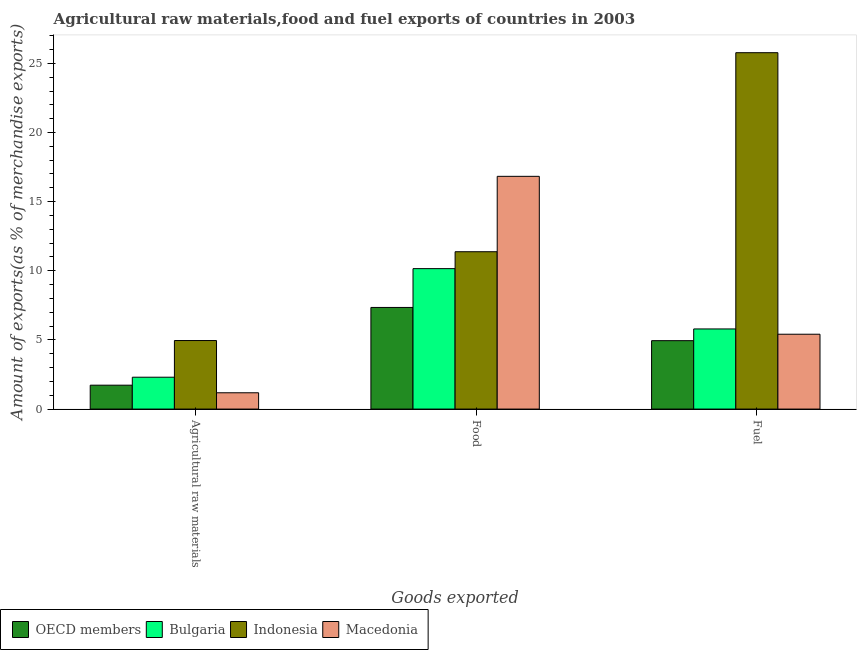Are the number of bars on each tick of the X-axis equal?
Your response must be concise. Yes. How many bars are there on the 1st tick from the left?
Give a very brief answer. 4. What is the label of the 2nd group of bars from the left?
Your response must be concise. Food. What is the percentage of food exports in OECD members?
Keep it short and to the point. 7.35. Across all countries, what is the maximum percentage of food exports?
Make the answer very short. 16.83. Across all countries, what is the minimum percentage of raw materials exports?
Ensure brevity in your answer.  1.18. In which country was the percentage of raw materials exports maximum?
Your answer should be very brief. Indonesia. What is the total percentage of fuel exports in the graph?
Your answer should be very brief. 41.93. What is the difference between the percentage of food exports in Bulgaria and that in Indonesia?
Give a very brief answer. -1.22. What is the difference between the percentage of raw materials exports in OECD members and the percentage of food exports in Indonesia?
Ensure brevity in your answer.  -9.65. What is the average percentage of food exports per country?
Your answer should be very brief. 11.43. What is the difference between the percentage of raw materials exports and percentage of food exports in OECD members?
Offer a very short reply. -5.62. What is the ratio of the percentage of raw materials exports in OECD members to that in Macedonia?
Offer a terse response. 1.47. What is the difference between the highest and the second highest percentage of food exports?
Provide a short and direct response. 5.45. What is the difference between the highest and the lowest percentage of food exports?
Provide a short and direct response. 9.48. In how many countries, is the percentage of fuel exports greater than the average percentage of fuel exports taken over all countries?
Your response must be concise. 1. Is the sum of the percentage of fuel exports in Indonesia and Macedonia greater than the maximum percentage of raw materials exports across all countries?
Ensure brevity in your answer.  Yes. What does the 2nd bar from the right in Fuel represents?
Provide a short and direct response. Indonesia. Is it the case that in every country, the sum of the percentage of raw materials exports and percentage of food exports is greater than the percentage of fuel exports?
Ensure brevity in your answer.  No. Are all the bars in the graph horizontal?
Make the answer very short. No. How many countries are there in the graph?
Offer a very short reply. 4. Does the graph contain any zero values?
Your answer should be compact. No. How many legend labels are there?
Provide a short and direct response. 4. How are the legend labels stacked?
Your answer should be very brief. Horizontal. What is the title of the graph?
Your answer should be very brief. Agricultural raw materials,food and fuel exports of countries in 2003. Does "Caribbean small states" appear as one of the legend labels in the graph?
Offer a terse response. No. What is the label or title of the X-axis?
Provide a succinct answer. Goods exported. What is the label or title of the Y-axis?
Provide a succinct answer. Amount of exports(as % of merchandise exports). What is the Amount of exports(as % of merchandise exports) in OECD members in Agricultural raw materials?
Offer a terse response. 1.73. What is the Amount of exports(as % of merchandise exports) of Bulgaria in Agricultural raw materials?
Offer a terse response. 2.3. What is the Amount of exports(as % of merchandise exports) of Indonesia in Agricultural raw materials?
Ensure brevity in your answer.  4.96. What is the Amount of exports(as % of merchandise exports) in Macedonia in Agricultural raw materials?
Provide a succinct answer. 1.18. What is the Amount of exports(as % of merchandise exports) in OECD members in Food?
Your answer should be compact. 7.35. What is the Amount of exports(as % of merchandise exports) of Bulgaria in Food?
Your answer should be compact. 10.16. What is the Amount of exports(as % of merchandise exports) in Indonesia in Food?
Your response must be concise. 11.38. What is the Amount of exports(as % of merchandise exports) in Macedonia in Food?
Provide a succinct answer. 16.83. What is the Amount of exports(as % of merchandise exports) of OECD members in Fuel?
Provide a succinct answer. 4.95. What is the Amount of exports(as % of merchandise exports) in Bulgaria in Fuel?
Offer a very short reply. 5.79. What is the Amount of exports(as % of merchandise exports) in Indonesia in Fuel?
Offer a terse response. 25.77. What is the Amount of exports(as % of merchandise exports) of Macedonia in Fuel?
Keep it short and to the point. 5.41. Across all Goods exported, what is the maximum Amount of exports(as % of merchandise exports) of OECD members?
Ensure brevity in your answer.  7.35. Across all Goods exported, what is the maximum Amount of exports(as % of merchandise exports) in Bulgaria?
Your answer should be compact. 10.16. Across all Goods exported, what is the maximum Amount of exports(as % of merchandise exports) of Indonesia?
Keep it short and to the point. 25.77. Across all Goods exported, what is the maximum Amount of exports(as % of merchandise exports) in Macedonia?
Offer a very short reply. 16.83. Across all Goods exported, what is the minimum Amount of exports(as % of merchandise exports) in OECD members?
Offer a very short reply. 1.73. Across all Goods exported, what is the minimum Amount of exports(as % of merchandise exports) in Bulgaria?
Ensure brevity in your answer.  2.3. Across all Goods exported, what is the minimum Amount of exports(as % of merchandise exports) in Indonesia?
Give a very brief answer. 4.96. Across all Goods exported, what is the minimum Amount of exports(as % of merchandise exports) in Macedonia?
Your response must be concise. 1.18. What is the total Amount of exports(as % of merchandise exports) of OECD members in the graph?
Ensure brevity in your answer.  14.02. What is the total Amount of exports(as % of merchandise exports) in Bulgaria in the graph?
Your answer should be very brief. 18.25. What is the total Amount of exports(as % of merchandise exports) in Indonesia in the graph?
Give a very brief answer. 42.11. What is the total Amount of exports(as % of merchandise exports) in Macedonia in the graph?
Your response must be concise. 23.42. What is the difference between the Amount of exports(as % of merchandise exports) in OECD members in Agricultural raw materials and that in Food?
Your response must be concise. -5.62. What is the difference between the Amount of exports(as % of merchandise exports) of Bulgaria in Agricultural raw materials and that in Food?
Provide a succinct answer. -7.85. What is the difference between the Amount of exports(as % of merchandise exports) in Indonesia in Agricultural raw materials and that in Food?
Offer a very short reply. -6.42. What is the difference between the Amount of exports(as % of merchandise exports) of Macedonia in Agricultural raw materials and that in Food?
Provide a succinct answer. -15.65. What is the difference between the Amount of exports(as % of merchandise exports) of OECD members in Agricultural raw materials and that in Fuel?
Your answer should be compact. -3.22. What is the difference between the Amount of exports(as % of merchandise exports) of Bulgaria in Agricultural raw materials and that in Fuel?
Provide a succinct answer. -3.49. What is the difference between the Amount of exports(as % of merchandise exports) in Indonesia in Agricultural raw materials and that in Fuel?
Provide a succinct answer. -20.81. What is the difference between the Amount of exports(as % of merchandise exports) of Macedonia in Agricultural raw materials and that in Fuel?
Ensure brevity in your answer.  -4.23. What is the difference between the Amount of exports(as % of merchandise exports) of OECD members in Food and that in Fuel?
Provide a succinct answer. 2.4. What is the difference between the Amount of exports(as % of merchandise exports) of Bulgaria in Food and that in Fuel?
Ensure brevity in your answer.  4.36. What is the difference between the Amount of exports(as % of merchandise exports) of Indonesia in Food and that in Fuel?
Keep it short and to the point. -14.39. What is the difference between the Amount of exports(as % of merchandise exports) of Macedonia in Food and that in Fuel?
Offer a very short reply. 11.42. What is the difference between the Amount of exports(as % of merchandise exports) in OECD members in Agricultural raw materials and the Amount of exports(as % of merchandise exports) in Bulgaria in Food?
Give a very brief answer. -8.43. What is the difference between the Amount of exports(as % of merchandise exports) in OECD members in Agricultural raw materials and the Amount of exports(as % of merchandise exports) in Indonesia in Food?
Give a very brief answer. -9.65. What is the difference between the Amount of exports(as % of merchandise exports) of OECD members in Agricultural raw materials and the Amount of exports(as % of merchandise exports) of Macedonia in Food?
Your answer should be compact. -15.1. What is the difference between the Amount of exports(as % of merchandise exports) in Bulgaria in Agricultural raw materials and the Amount of exports(as % of merchandise exports) in Indonesia in Food?
Your answer should be compact. -9.07. What is the difference between the Amount of exports(as % of merchandise exports) of Bulgaria in Agricultural raw materials and the Amount of exports(as % of merchandise exports) of Macedonia in Food?
Your answer should be compact. -14.53. What is the difference between the Amount of exports(as % of merchandise exports) in Indonesia in Agricultural raw materials and the Amount of exports(as % of merchandise exports) in Macedonia in Food?
Provide a succinct answer. -11.87. What is the difference between the Amount of exports(as % of merchandise exports) in OECD members in Agricultural raw materials and the Amount of exports(as % of merchandise exports) in Bulgaria in Fuel?
Your response must be concise. -4.07. What is the difference between the Amount of exports(as % of merchandise exports) of OECD members in Agricultural raw materials and the Amount of exports(as % of merchandise exports) of Indonesia in Fuel?
Ensure brevity in your answer.  -24.04. What is the difference between the Amount of exports(as % of merchandise exports) in OECD members in Agricultural raw materials and the Amount of exports(as % of merchandise exports) in Macedonia in Fuel?
Make the answer very short. -3.68. What is the difference between the Amount of exports(as % of merchandise exports) of Bulgaria in Agricultural raw materials and the Amount of exports(as % of merchandise exports) of Indonesia in Fuel?
Your answer should be compact. -23.47. What is the difference between the Amount of exports(as % of merchandise exports) of Bulgaria in Agricultural raw materials and the Amount of exports(as % of merchandise exports) of Macedonia in Fuel?
Provide a short and direct response. -3.11. What is the difference between the Amount of exports(as % of merchandise exports) of Indonesia in Agricultural raw materials and the Amount of exports(as % of merchandise exports) of Macedonia in Fuel?
Your answer should be compact. -0.46. What is the difference between the Amount of exports(as % of merchandise exports) in OECD members in Food and the Amount of exports(as % of merchandise exports) in Bulgaria in Fuel?
Ensure brevity in your answer.  1.55. What is the difference between the Amount of exports(as % of merchandise exports) of OECD members in Food and the Amount of exports(as % of merchandise exports) of Indonesia in Fuel?
Provide a succinct answer. -18.42. What is the difference between the Amount of exports(as % of merchandise exports) in OECD members in Food and the Amount of exports(as % of merchandise exports) in Macedonia in Fuel?
Provide a succinct answer. 1.94. What is the difference between the Amount of exports(as % of merchandise exports) of Bulgaria in Food and the Amount of exports(as % of merchandise exports) of Indonesia in Fuel?
Your answer should be very brief. -15.62. What is the difference between the Amount of exports(as % of merchandise exports) in Bulgaria in Food and the Amount of exports(as % of merchandise exports) in Macedonia in Fuel?
Provide a short and direct response. 4.74. What is the difference between the Amount of exports(as % of merchandise exports) in Indonesia in Food and the Amount of exports(as % of merchandise exports) in Macedonia in Fuel?
Your answer should be very brief. 5.97. What is the average Amount of exports(as % of merchandise exports) of OECD members per Goods exported?
Make the answer very short. 4.67. What is the average Amount of exports(as % of merchandise exports) in Bulgaria per Goods exported?
Provide a succinct answer. 6.08. What is the average Amount of exports(as % of merchandise exports) in Indonesia per Goods exported?
Your response must be concise. 14.04. What is the average Amount of exports(as % of merchandise exports) in Macedonia per Goods exported?
Offer a terse response. 7.81. What is the difference between the Amount of exports(as % of merchandise exports) in OECD members and Amount of exports(as % of merchandise exports) in Bulgaria in Agricultural raw materials?
Your response must be concise. -0.58. What is the difference between the Amount of exports(as % of merchandise exports) of OECD members and Amount of exports(as % of merchandise exports) of Indonesia in Agricultural raw materials?
Provide a succinct answer. -3.23. What is the difference between the Amount of exports(as % of merchandise exports) of OECD members and Amount of exports(as % of merchandise exports) of Macedonia in Agricultural raw materials?
Your response must be concise. 0.55. What is the difference between the Amount of exports(as % of merchandise exports) in Bulgaria and Amount of exports(as % of merchandise exports) in Indonesia in Agricultural raw materials?
Provide a succinct answer. -2.65. What is the difference between the Amount of exports(as % of merchandise exports) in Bulgaria and Amount of exports(as % of merchandise exports) in Macedonia in Agricultural raw materials?
Your answer should be compact. 1.13. What is the difference between the Amount of exports(as % of merchandise exports) of Indonesia and Amount of exports(as % of merchandise exports) of Macedonia in Agricultural raw materials?
Keep it short and to the point. 3.78. What is the difference between the Amount of exports(as % of merchandise exports) of OECD members and Amount of exports(as % of merchandise exports) of Bulgaria in Food?
Make the answer very short. -2.81. What is the difference between the Amount of exports(as % of merchandise exports) of OECD members and Amount of exports(as % of merchandise exports) of Indonesia in Food?
Give a very brief answer. -4.03. What is the difference between the Amount of exports(as % of merchandise exports) in OECD members and Amount of exports(as % of merchandise exports) in Macedonia in Food?
Make the answer very short. -9.48. What is the difference between the Amount of exports(as % of merchandise exports) of Bulgaria and Amount of exports(as % of merchandise exports) of Indonesia in Food?
Your response must be concise. -1.22. What is the difference between the Amount of exports(as % of merchandise exports) of Bulgaria and Amount of exports(as % of merchandise exports) of Macedonia in Food?
Offer a very short reply. -6.67. What is the difference between the Amount of exports(as % of merchandise exports) in Indonesia and Amount of exports(as % of merchandise exports) in Macedonia in Food?
Your answer should be compact. -5.45. What is the difference between the Amount of exports(as % of merchandise exports) of OECD members and Amount of exports(as % of merchandise exports) of Bulgaria in Fuel?
Ensure brevity in your answer.  -0.85. What is the difference between the Amount of exports(as % of merchandise exports) of OECD members and Amount of exports(as % of merchandise exports) of Indonesia in Fuel?
Provide a short and direct response. -20.82. What is the difference between the Amount of exports(as % of merchandise exports) of OECD members and Amount of exports(as % of merchandise exports) of Macedonia in Fuel?
Provide a succinct answer. -0.47. What is the difference between the Amount of exports(as % of merchandise exports) of Bulgaria and Amount of exports(as % of merchandise exports) of Indonesia in Fuel?
Make the answer very short. -19.98. What is the difference between the Amount of exports(as % of merchandise exports) in Bulgaria and Amount of exports(as % of merchandise exports) in Macedonia in Fuel?
Make the answer very short. 0.38. What is the difference between the Amount of exports(as % of merchandise exports) in Indonesia and Amount of exports(as % of merchandise exports) in Macedonia in Fuel?
Offer a terse response. 20.36. What is the ratio of the Amount of exports(as % of merchandise exports) of OECD members in Agricultural raw materials to that in Food?
Your response must be concise. 0.24. What is the ratio of the Amount of exports(as % of merchandise exports) of Bulgaria in Agricultural raw materials to that in Food?
Offer a terse response. 0.23. What is the ratio of the Amount of exports(as % of merchandise exports) in Indonesia in Agricultural raw materials to that in Food?
Ensure brevity in your answer.  0.44. What is the ratio of the Amount of exports(as % of merchandise exports) in Macedonia in Agricultural raw materials to that in Food?
Your response must be concise. 0.07. What is the ratio of the Amount of exports(as % of merchandise exports) of OECD members in Agricultural raw materials to that in Fuel?
Provide a succinct answer. 0.35. What is the ratio of the Amount of exports(as % of merchandise exports) of Bulgaria in Agricultural raw materials to that in Fuel?
Provide a succinct answer. 0.4. What is the ratio of the Amount of exports(as % of merchandise exports) of Indonesia in Agricultural raw materials to that in Fuel?
Offer a terse response. 0.19. What is the ratio of the Amount of exports(as % of merchandise exports) of Macedonia in Agricultural raw materials to that in Fuel?
Ensure brevity in your answer.  0.22. What is the ratio of the Amount of exports(as % of merchandise exports) in OECD members in Food to that in Fuel?
Give a very brief answer. 1.49. What is the ratio of the Amount of exports(as % of merchandise exports) in Bulgaria in Food to that in Fuel?
Provide a succinct answer. 1.75. What is the ratio of the Amount of exports(as % of merchandise exports) in Indonesia in Food to that in Fuel?
Keep it short and to the point. 0.44. What is the ratio of the Amount of exports(as % of merchandise exports) of Macedonia in Food to that in Fuel?
Your answer should be compact. 3.11. What is the difference between the highest and the second highest Amount of exports(as % of merchandise exports) in OECD members?
Your answer should be very brief. 2.4. What is the difference between the highest and the second highest Amount of exports(as % of merchandise exports) of Bulgaria?
Give a very brief answer. 4.36. What is the difference between the highest and the second highest Amount of exports(as % of merchandise exports) of Indonesia?
Give a very brief answer. 14.39. What is the difference between the highest and the second highest Amount of exports(as % of merchandise exports) of Macedonia?
Your answer should be compact. 11.42. What is the difference between the highest and the lowest Amount of exports(as % of merchandise exports) in OECD members?
Your response must be concise. 5.62. What is the difference between the highest and the lowest Amount of exports(as % of merchandise exports) of Bulgaria?
Ensure brevity in your answer.  7.85. What is the difference between the highest and the lowest Amount of exports(as % of merchandise exports) of Indonesia?
Make the answer very short. 20.81. What is the difference between the highest and the lowest Amount of exports(as % of merchandise exports) of Macedonia?
Provide a succinct answer. 15.65. 